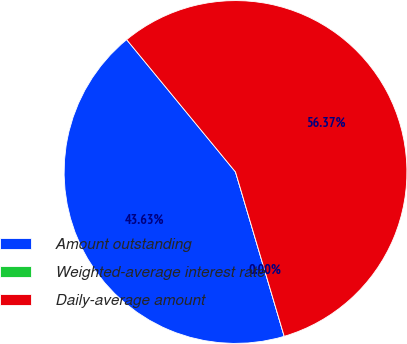<chart> <loc_0><loc_0><loc_500><loc_500><pie_chart><fcel>Amount outstanding<fcel>Weighted-average interest rate<fcel>Daily-average amount<nl><fcel>43.63%<fcel>0.0%<fcel>56.37%<nl></chart> 